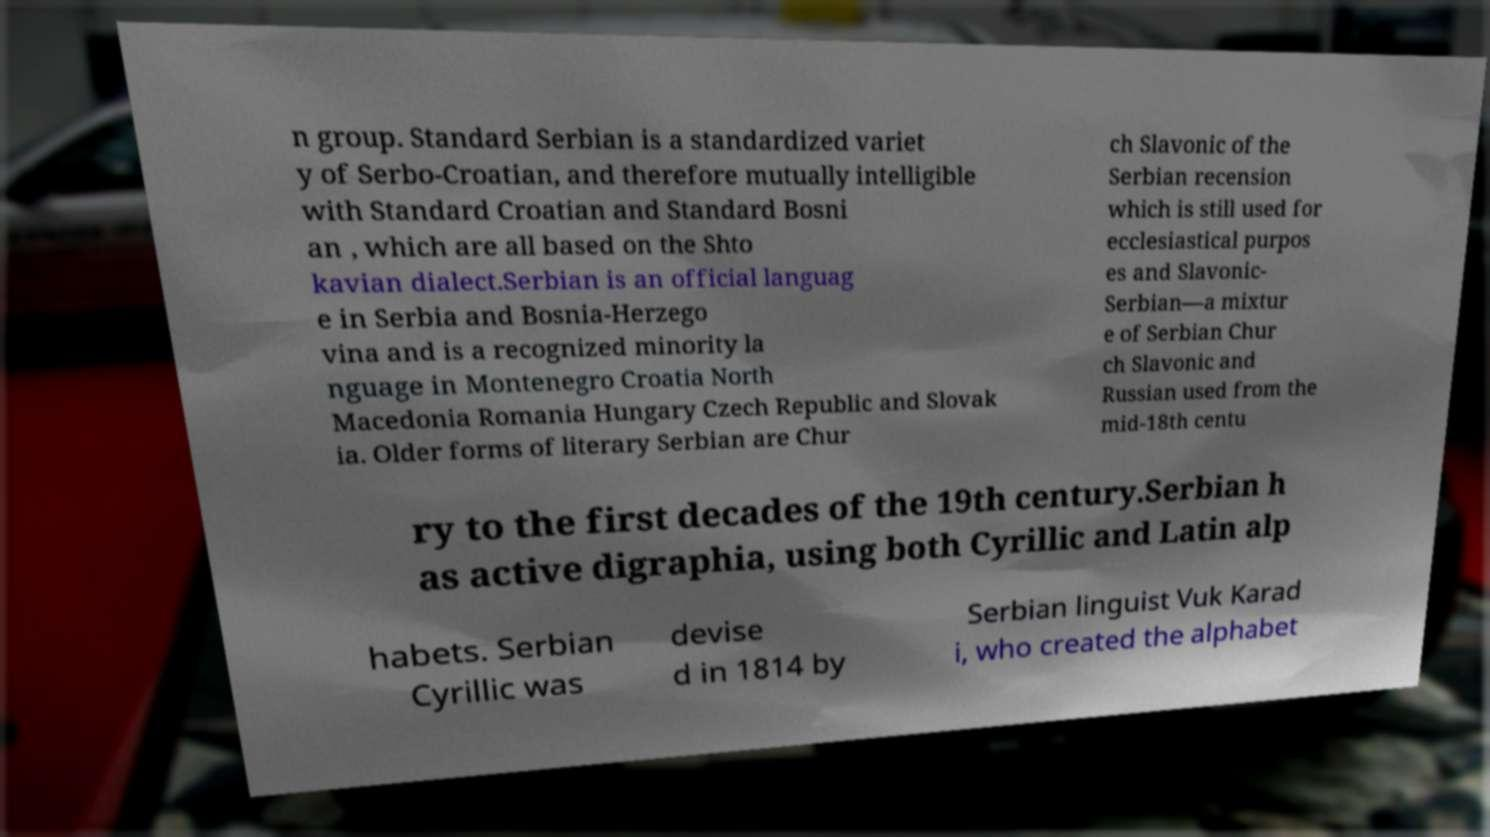There's text embedded in this image that I need extracted. Can you transcribe it verbatim? n group. Standard Serbian is a standardized variet y of Serbo-Croatian, and therefore mutually intelligible with Standard Croatian and Standard Bosni an , which are all based on the Shto kavian dialect.Serbian is an official languag e in Serbia and Bosnia-Herzego vina and is a recognized minority la nguage in Montenegro Croatia North Macedonia Romania Hungary Czech Republic and Slovak ia. Older forms of literary Serbian are Chur ch Slavonic of the Serbian recension which is still used for ecclesiastical purpos es and Slavonic- Serbian—a mixtur e of Serbian Chur ch Slavonic and Russian used from the mid-18th centu ry to the first decades of the 19th century.Serbian h as active digraphia, using both Cyrillic and Latin alp habets. Serbian Cyrillic was devise d in 1814 by Serbian linguist Vuk Karad i, who created the alphabet 